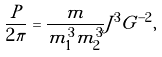Convert formula to latex. <formula><loc_0><loc_0><loc_500><loc_500>\frac { P } { 2 \pi } = \frac { m } { m _ { 1 } ^ { 3 } m _ { 2 } ^ { 3 } } J ^ { 3 } G ^ { - 2 } ,</formula> 